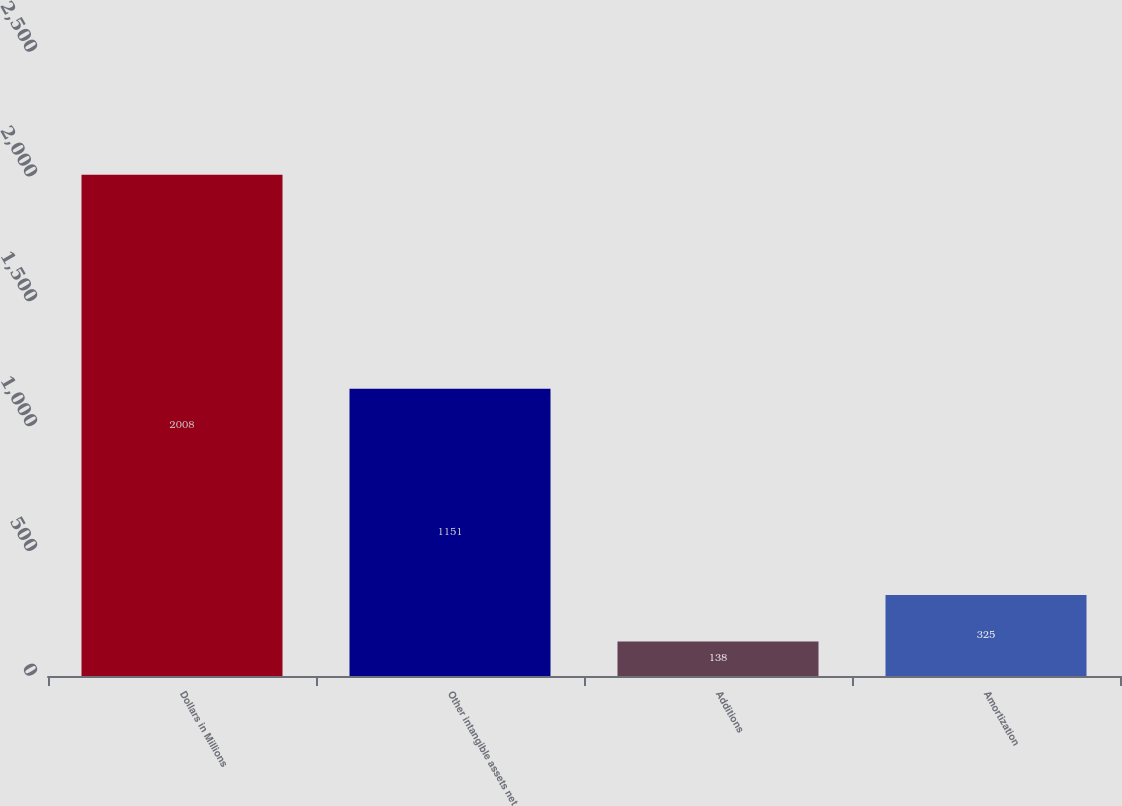Convert chart to OTSL. <chart><loc_0><loc_0><loc_500><loc_500><bar_chart><fcel>Dollars in Millions<fcel>Other intangible assets net<fcel>Additions<fcel>Amortization<nl><fcel>2008<fcel>1151<fcel>138<fcel>325<nl></chart> 